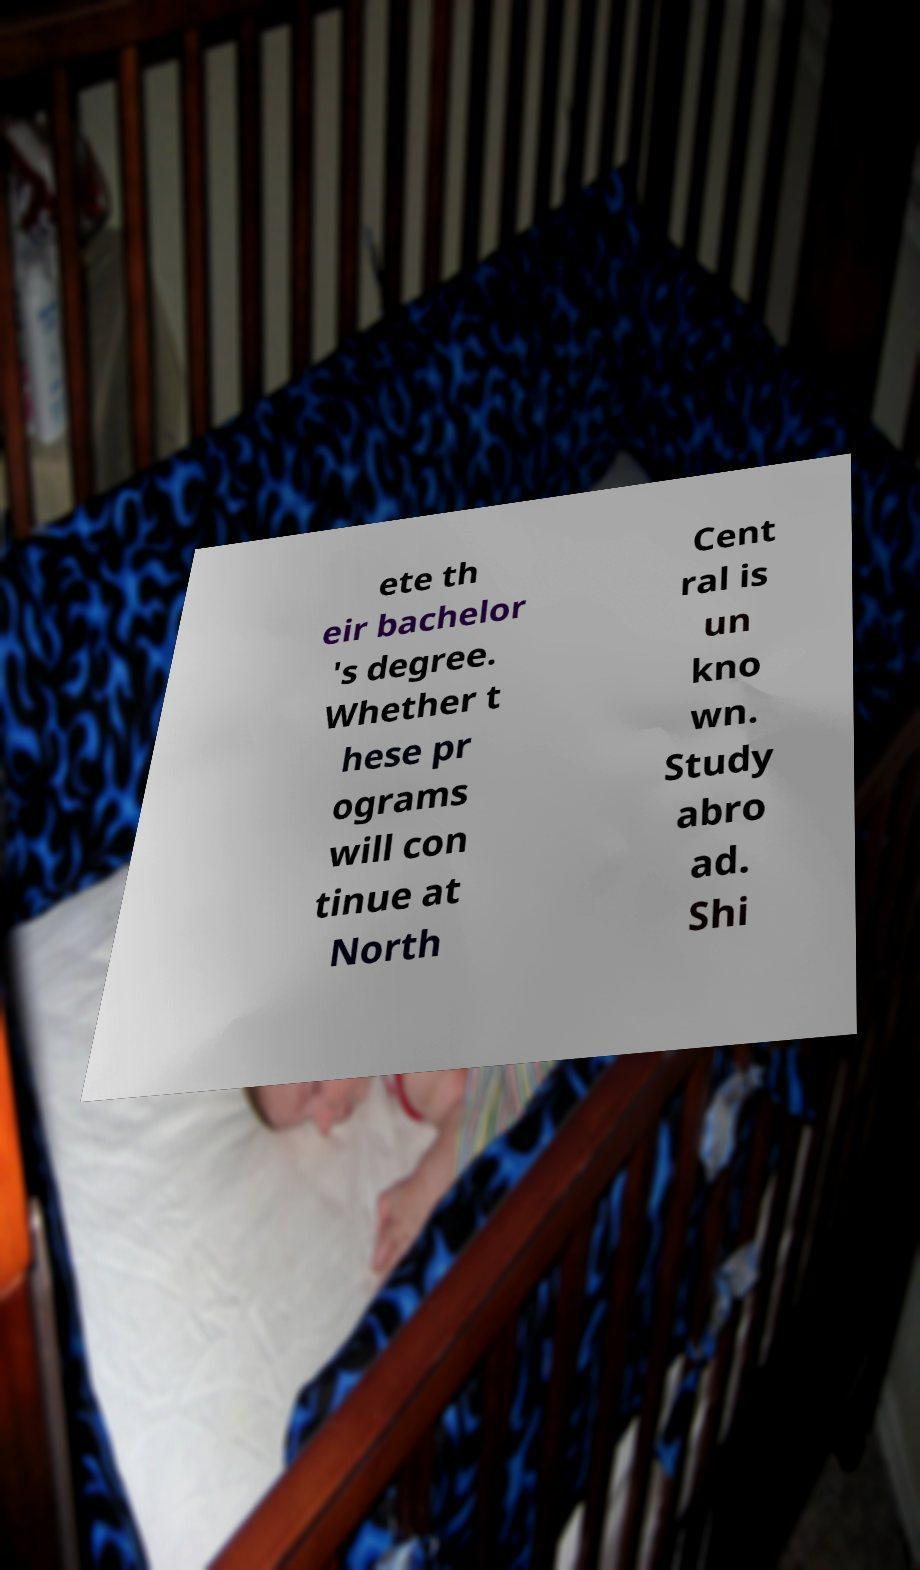Can you accurately transcribe the text from the provided image for me? ete th eir bachelor 's degree. Whether t hese pr ograms will con tinue at North Cent ral is un kno wn. Study abro ad. Shi 